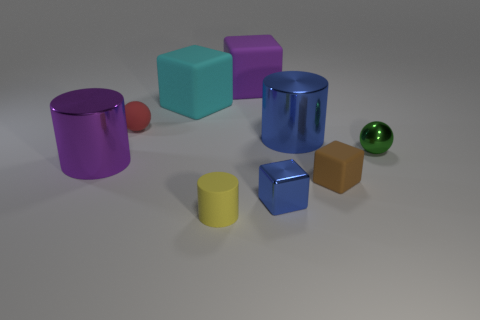There is a tiny rubber thing that is behind the large purple thing on the left side of the matte cylinder; are there any big metal cylinders on the left side of it?
Keep it short and to the point. Yes. What is the color of the other tiny shiny thing that is the same shape as the cyan object?
Your answer should be compact. Blue. How many blue things are either metallic blocks or rubber cubes?
Your answer should be very brief. 1. The blue cylinder that is in front of the purple object that is behind the green sphere is made of what material?
Give a very brief answer. Metal. Do the yellow thing and the purple metallic thing have the same shape?
Your answer should be very brief. Yes. What color is the block that is the same size as the purple matte object?
Your answer should be compact. Cyan. Are there any large cylinders that have the same color as the small metal block?
Provide a succinct answer. Yes. Are there any small shiny cubes?
Your response must be concise. Yes. Do the sphere that is to the left of the big blue cylinder and the small green ball have the same material?
Ensure brevity in your answer.  No. What number of other objects have the same size as the brown thing?
Keep it short and to the point. 4. 